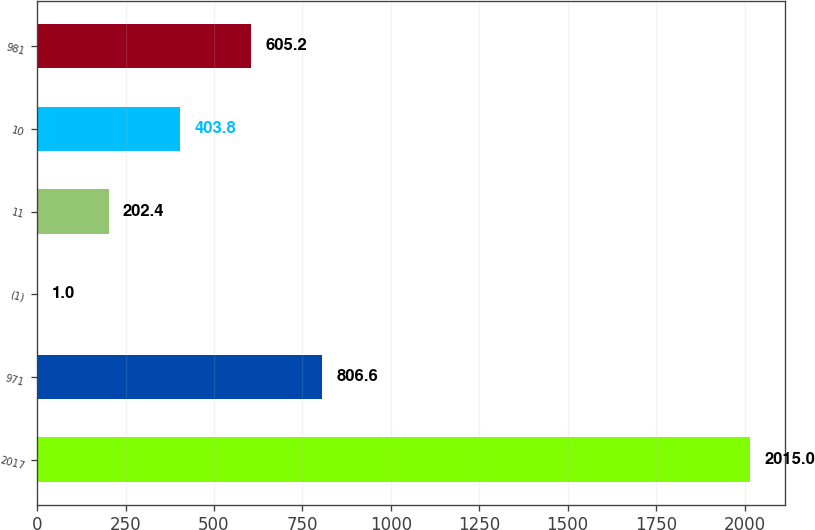<chart> <loc_0><loc_0><loc_500><loc_500><bar_chart><fcel>2017<fcel>971<fcel>(1)<fcel>11<fcel>10<fcel>981<nl><fcel>2015<fcel>806.6<fcel>1<fcel>202.4<fcel>403.8<fcel>605.2<nl></chart> 